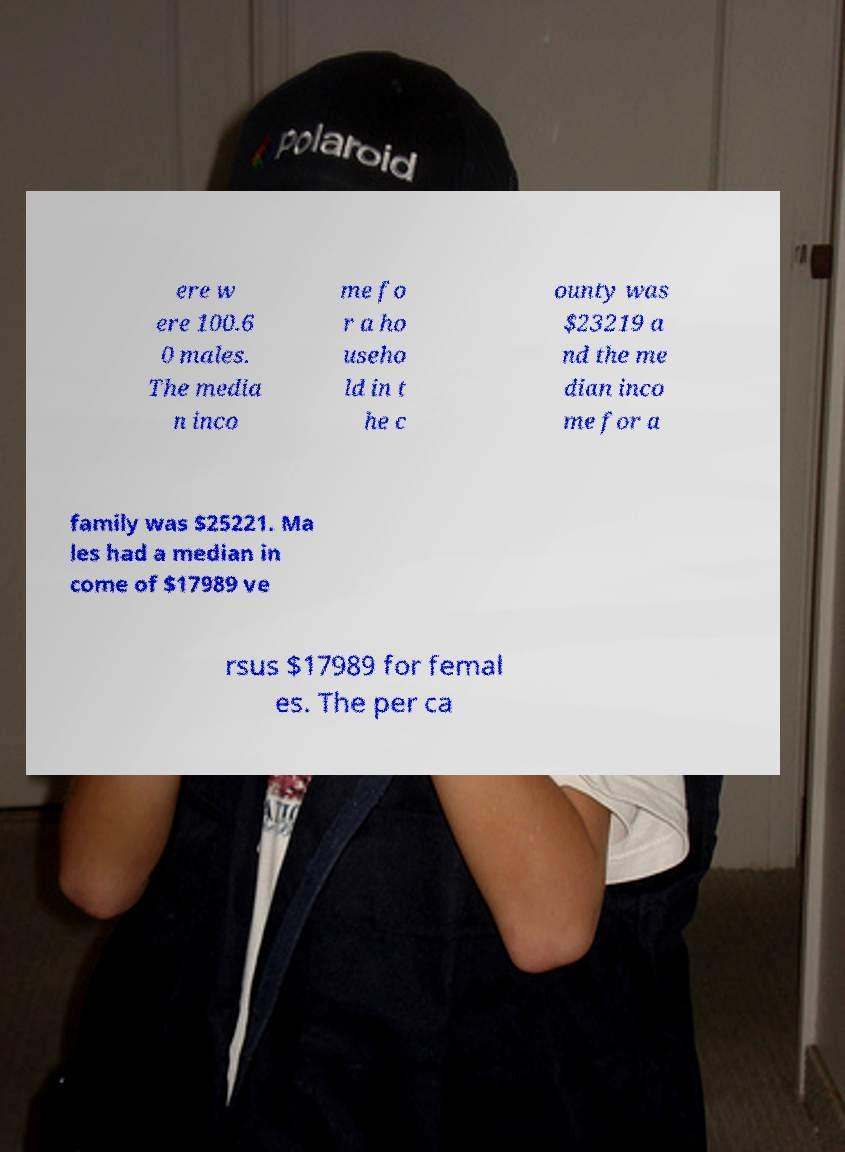Can you read and provide the text displayed in the image?This photo seems to have some interesting text. Can you extract and type it out for me? ere w ere 100.6 0 males. The media n inco me fo r a ho useho ld in t he c ounty was $23219 a nd the me dian inco me for a family was $25221. Ma les had a median in come of $17989 ve rsus $17989 for femal es. The per ca 